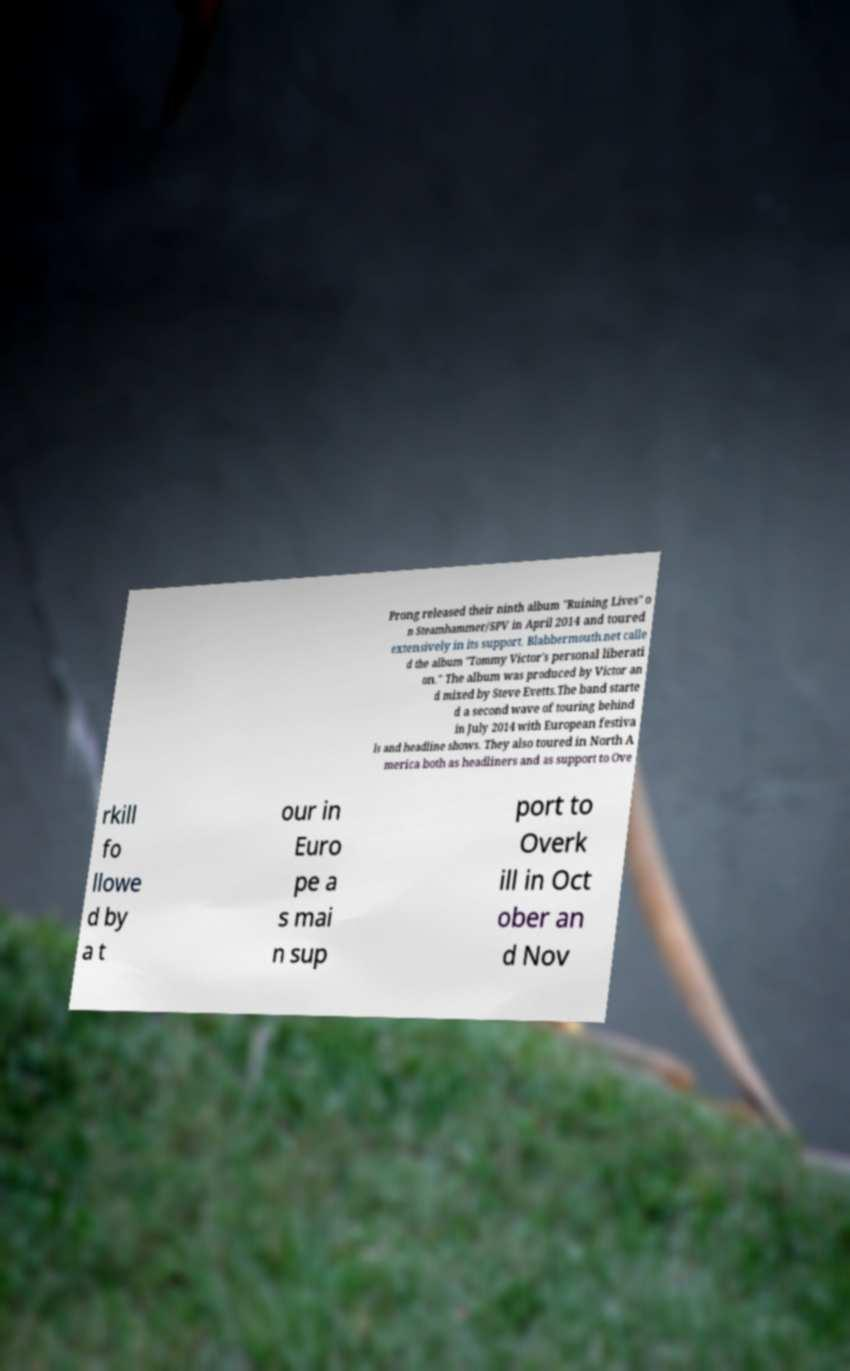There's text embedded in this image that I need extracted. Can you transcribe it verbatim? Prong released their ninth album "Ruining Lives" o n Steamhammer/SPV in April 2014 and toured extensively in its support. Blabbermouth.net calle d the album "Tommy Victor's personal liberati on." The album was produced by Victor an d mixed by Steve Evetts.The band starte d a second wave of touring behind in July 2014 with European festiva ls and headline shows. They also toured in North A merica both as headliners and as support to Ove rkill fo llowe d by a t our in Euro pe a s mai n sup port to Overk ill in Oct ober an d Nov 